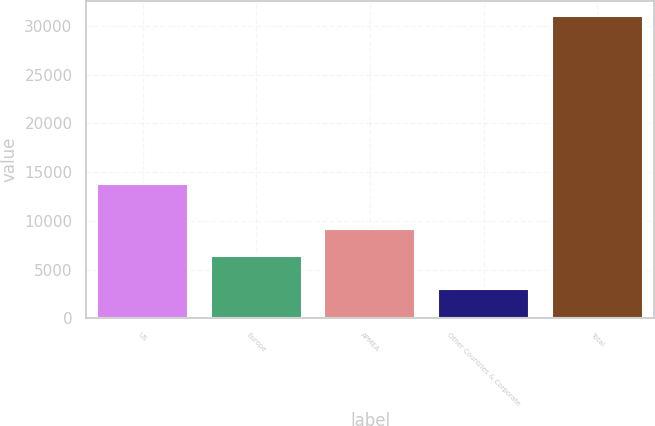Convert chart. <chart><loc_0><loc_0><loc_500><loc_500><bar_chart><fcel>US<fcel>Europe<fcel>APMEA<fcel>Other Countries & Corporate<fcel>Total<nl><fcel>13774<fcel>6403<fcel>9202.9<fcel>3047<fcel>31046<nl></chart> 